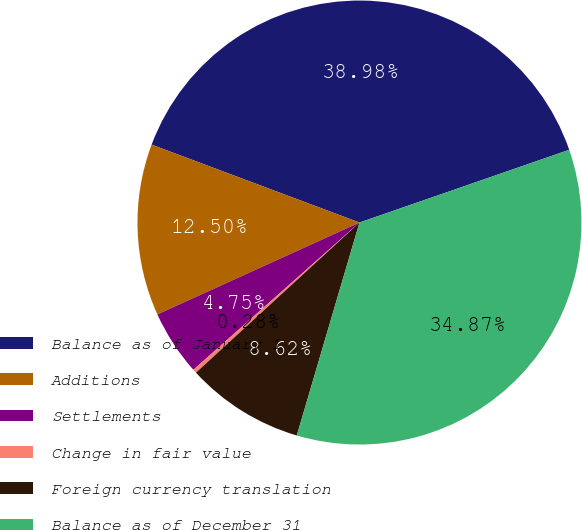Convert chart. <chart><loc_0><loc_0><loc_500><loc_500><pie_chart><fcel>Balance as of January 1<fcel>Additions<fcel>Settlements<fcel>Change in fair value<fcel>Foreign currency translation<fcel>Balance as of December 31<nl><fcel>38.98%<fcel>12.5%<fcel>4.75%<fcel>0.28%<fcel>8.62%<fcel>34.87%<nl></chart> 